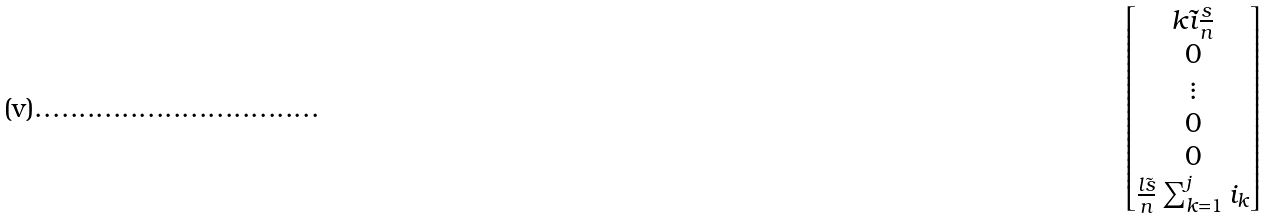<formula> <loc_0><loc_0><loc_500><loc_500>\begin{bmatrix} k \tilde { i } \frac { s } { n } \\ 0 \\ \vdots \\ 0 \\ 0 \\ \frac { l \tilde { s } } { n } \sum _ { k = 1 } ^ { j } i _ { k } \end{bmatrix}</formula> 